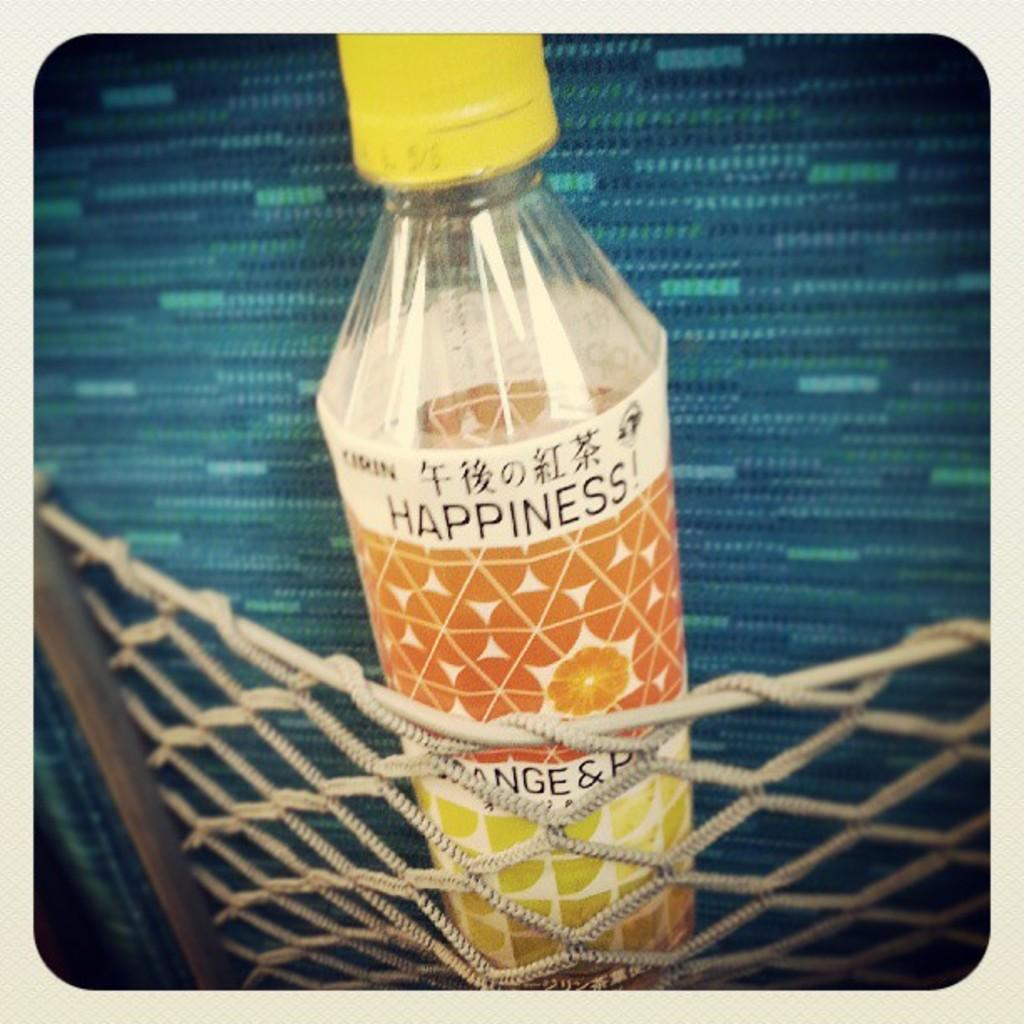<image>
Relay a brief, clear account of the picture shown. a bottle in a back pocket that says 'happiness' on it 